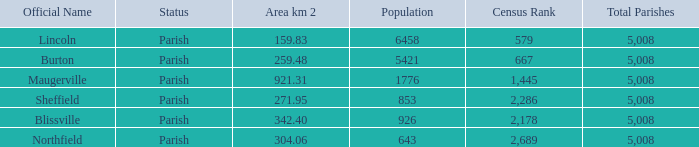What are the official name(s) of places with an area of 304.06 km2? Northfield. 